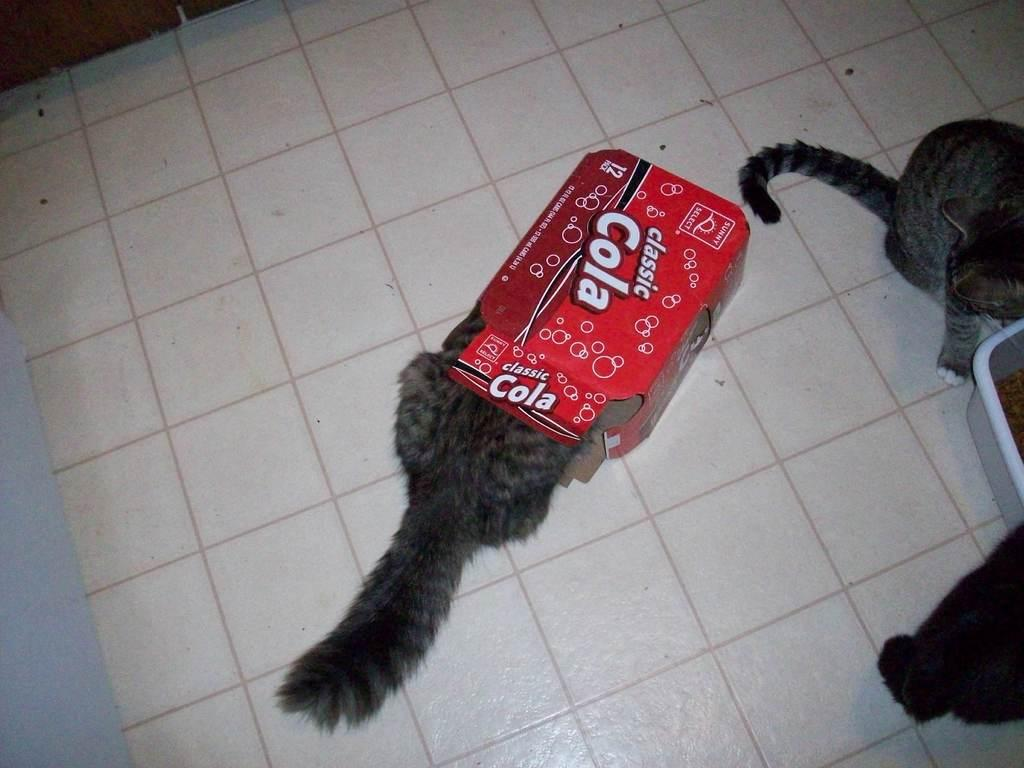What is inside the box in the image? There is a cat in a box in the image. Where are the other cats located in the image? There are cats on the right side of the image. What object can be seen in the image that might hold items? There is a container in the image. What surface is visible in the image? The floor is visible in the image. What type of insect is crawling on the cat's fur in the image? There is no insect present in the image; it only features cats and a container. 